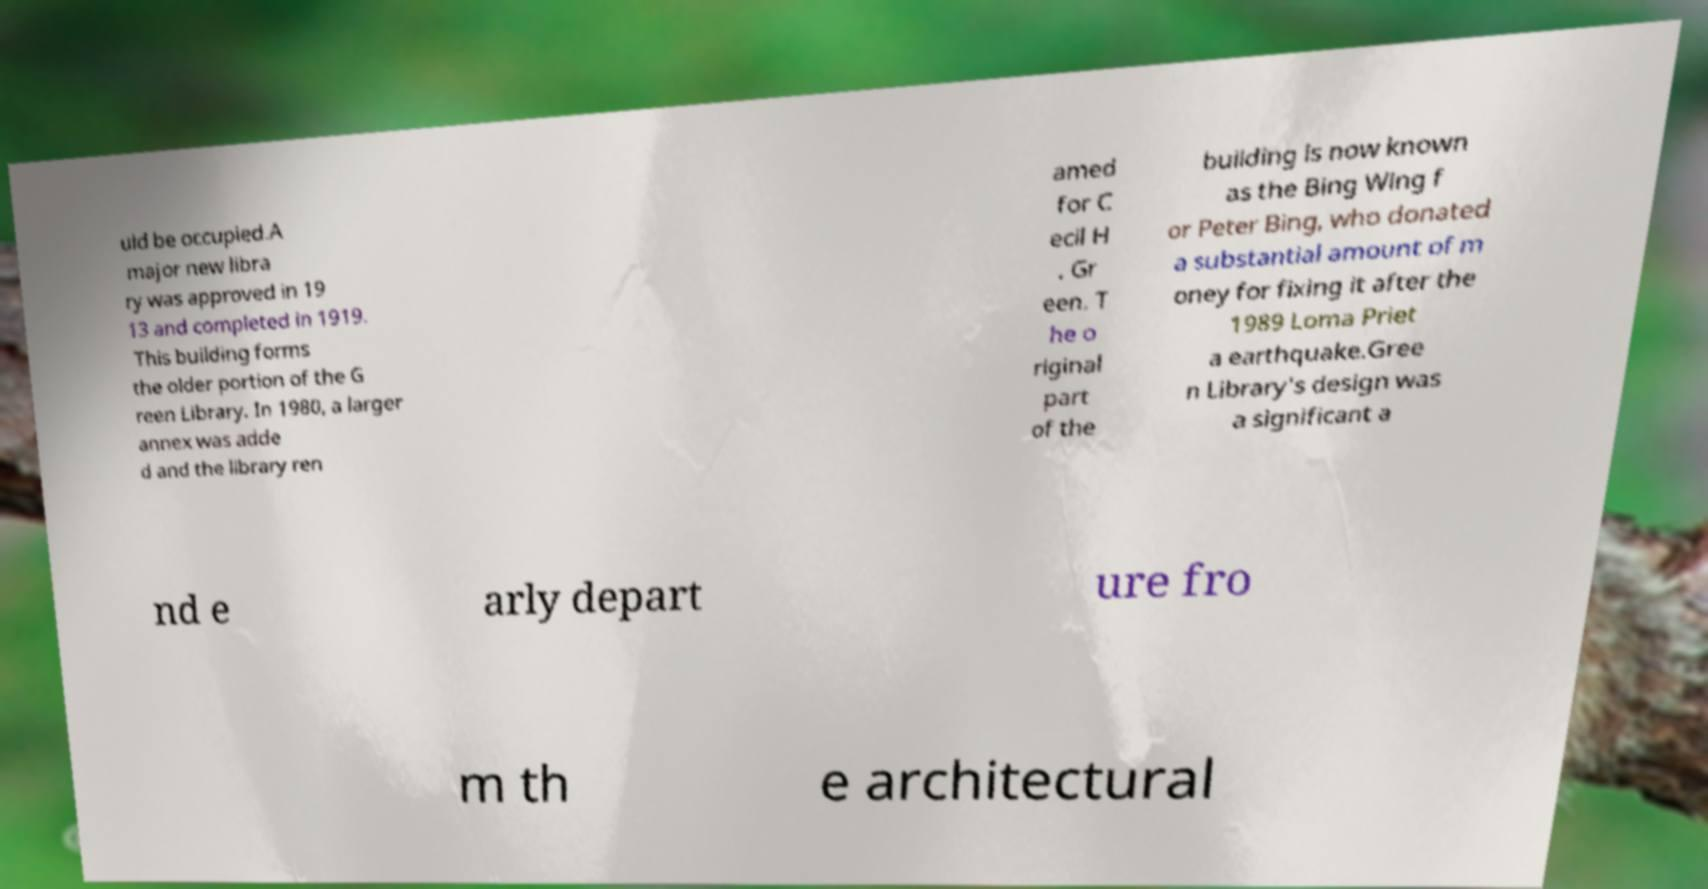I need the written content from this picture converted into text. Can you do that? uld be occupied.A major new libra ry was approved in 19 13 and completed in 1919. This building forms the older portion of the G reen Library. In 1980, a larger annex was adde d and the library ren amed for C ecil H . Gr een. T he o riginal part of the building is now known as the Bing Wing f or Peter Bing, who donated a substantial amount of m oney for fixing it after the 1989 Loma Priet a earthquake.Gree n Library's design was a significant a nd e arly depart ure fro m th e architectural 